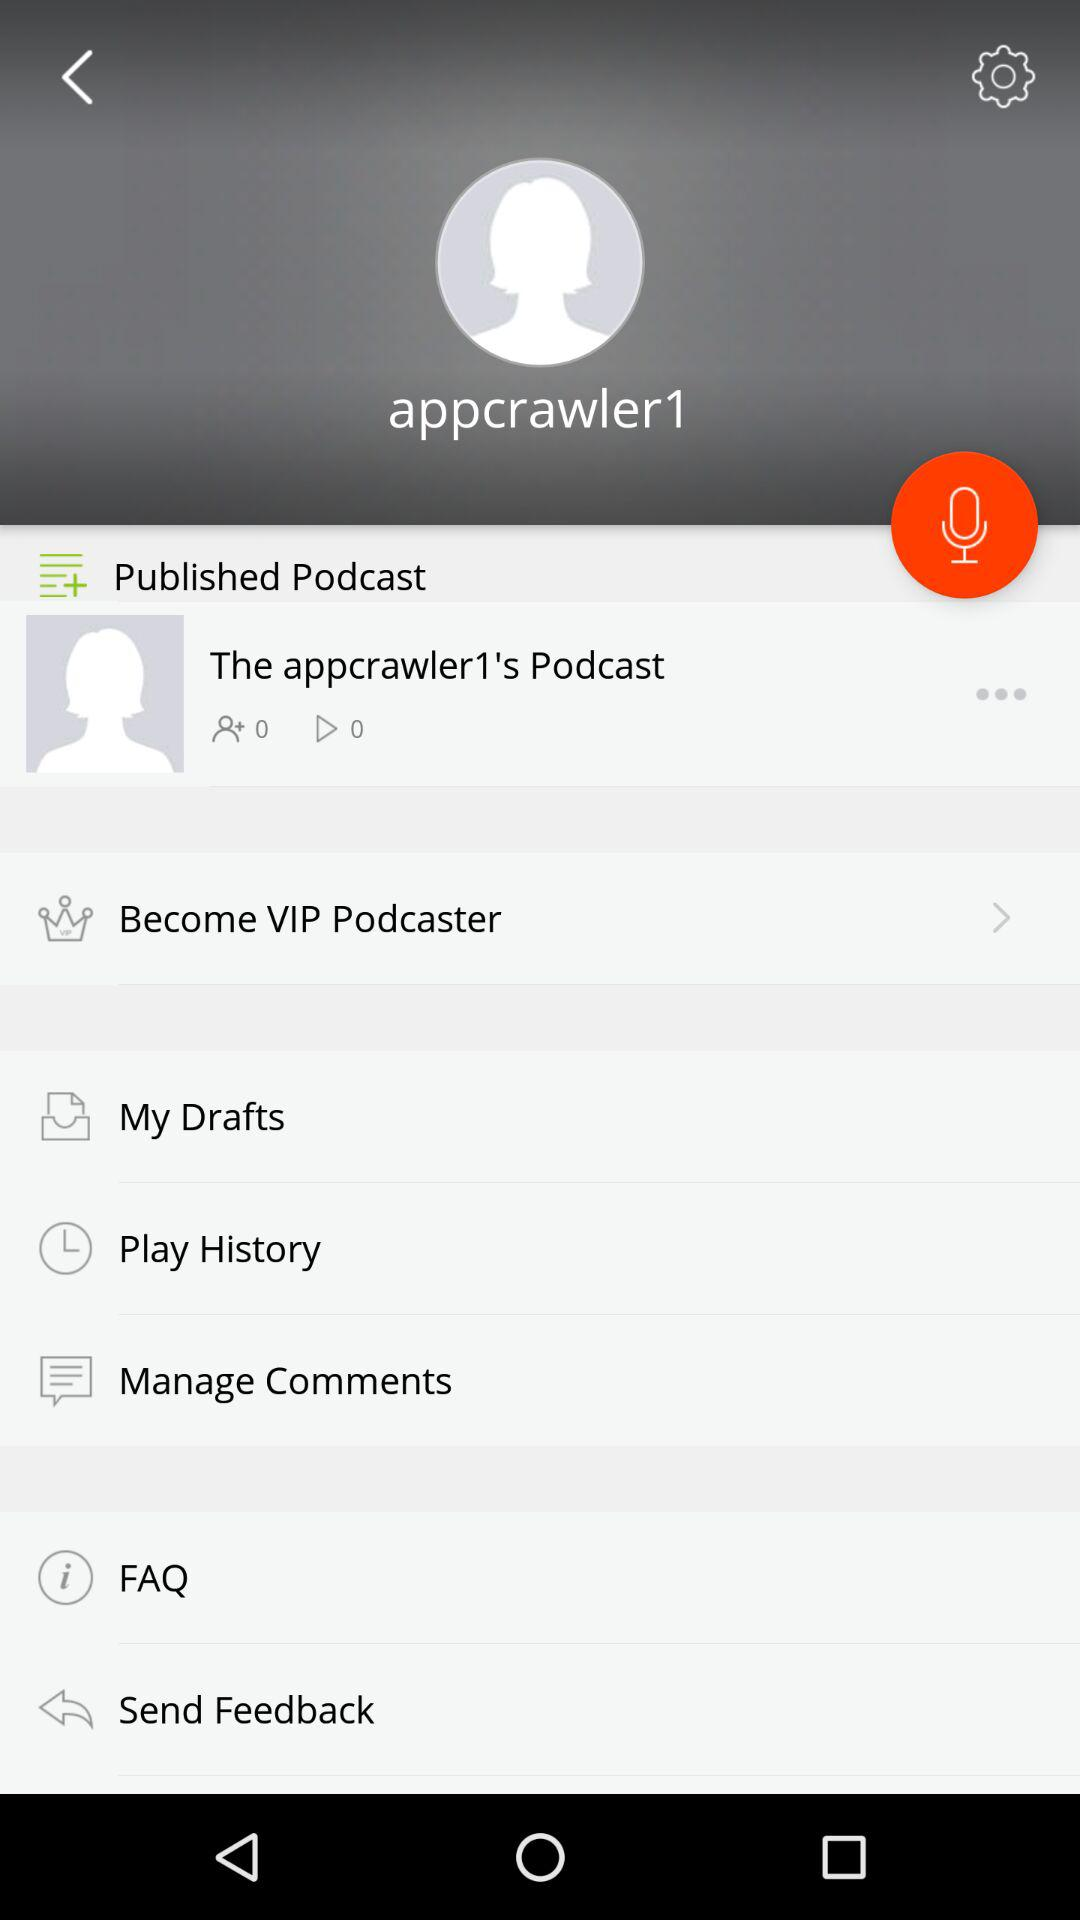What is the user name? The user name is "appcrawler1". 